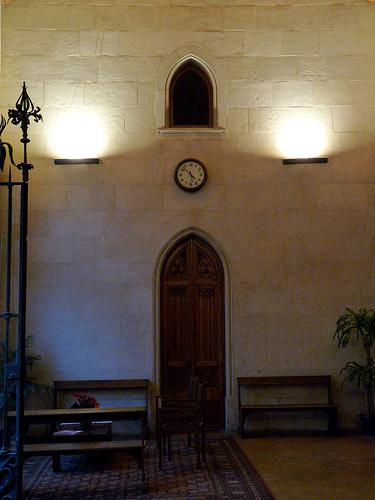Mention three architectural details of the building in the image. The building has an arched wooden door, a window above the door with an arched top, and a black and white clock on the wall above the door. Describe the clock in the image. The clock has a black and white face, a brown frame, and is hanging on the wall above the wooden door. What type of decoration is on the floor of the building? There is a rug with designs in various colors and patterns on the floor of the building. What are some elements you can find around the entrance of the building? There is a brown wooden bench, a rug on the floor, a potted plant with green leaves, and a metal gate with sharp points at the top. Describe the lighting fixtures in the image. There are two lights: one bright white light fixture on the right side of the building, and another light on the left side of the wall. List the types of furniture present in the image. The furniture includes a brown wooden chair, a wooden bench, and a brown table with magazines. What elements are seen around the door in the image? A wooden bench, a rug, a metal gate, a potted plant, and a window with an arched top are around the door. What kind of plant can be seen in the picture? There are two plants: a potted plant with green leaves and an orange plant with red flowers, which is possibly a poinsettia plant. Tell me about the door in this image. The door is a large wooden brown door, positioned within an arch in the middle of the building. Provide a brief overview of the image's components. The image features a building with white walls, a wooden door, windows, lights, a clock, a bench, plants, a rug, a metal gate, and some furniture. 